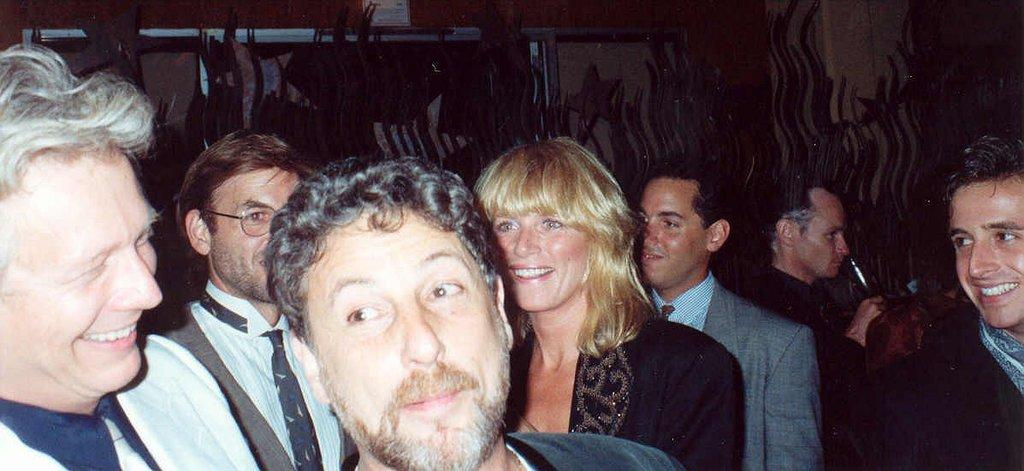What is the main subject of the image? The main subject of the image is people. Can you describe the location of the people in the image? The people are in the center of the image. What type of songs are the people singing in the image? There is no information about songs or singing in the image, as the facts only mention the presence of people. 